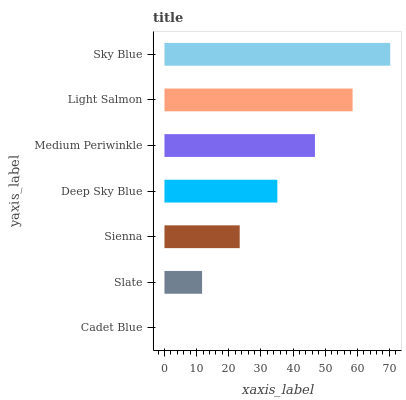Is Cadet Blue the minimum?
Answer yes or no. Yes. Is Sky Blue the maximum?
Answer yes or no. Yes. Is Slate the minimum?
Answer yes or no. No. Is Slate the maximum?
Answer yes or no. No. Is Slate greater than Cadet Blue?
Answer yes or no. Yes. Is Cadet Blue less than Slate?
Answer yes or no. Yes. Is Cadet Blue greater than Slate?
Answer yes or no. No. Is Slate less than Cadet Blue?
Answer yes or no. No. Is Deep Sky Blue the high median?
Answer yes or no. Yes. Is Deep Sky Blue the low median?
Answer yes or no. Yes. Is Sienna the high median?
Answer yes or no. No. Is Slate the low median?
Answer yes or no. No. 